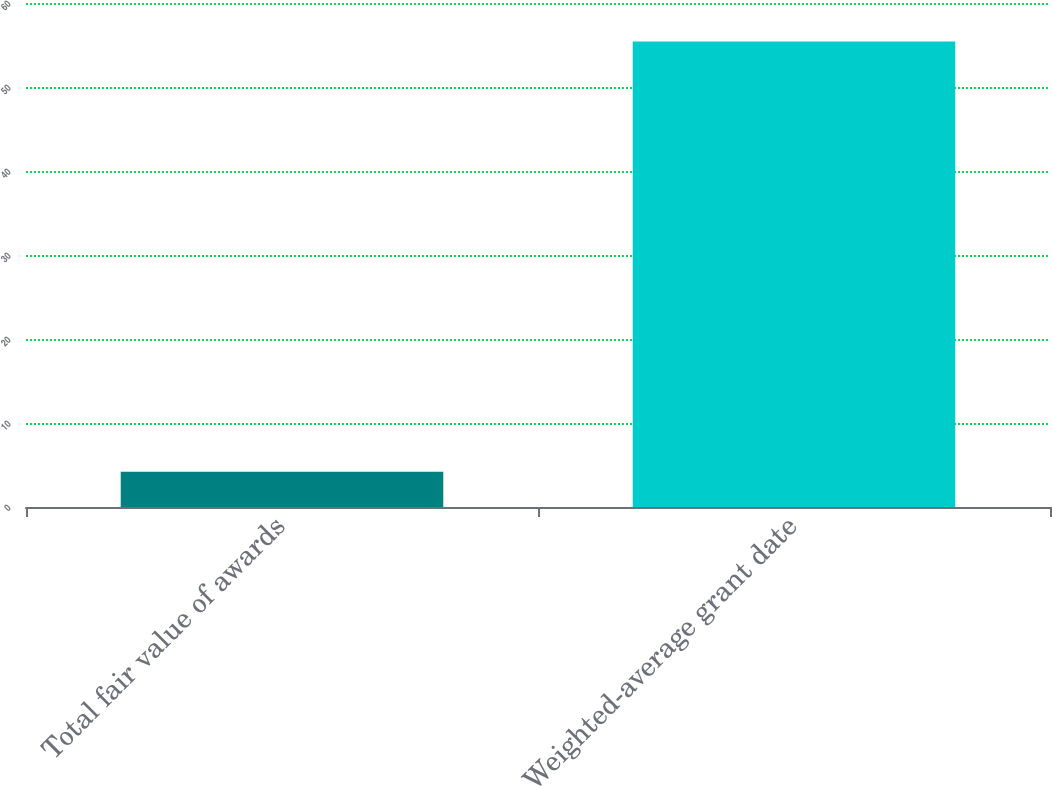Convert chart. <chart><loc_0><loc_0><loc_500><loc_500><bar_chart><fcel>Total fair value of awards<fcel>Weighted-average grant date<nl><fcel>4.2<fcel>55.43<nl></chart> 